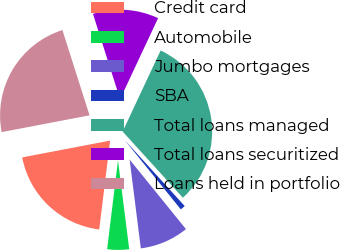<chart> <loc_0><loc_0><loc_500><loc_500><pie_chart><fcel>Credit card<fcel>Automobile<fcel>Jumbo mortgages<fcel>SBA<fcel>Total loans managed<fcel>Total loans securitized<fcel>Loans held in portfolio<nl><fcel>20.06%<fcel>3.94%<fcel>8.84%<fcel>0.91%<fcel>31.28%<fcel>11.88%<fcel>23.1%<nl></chart> 